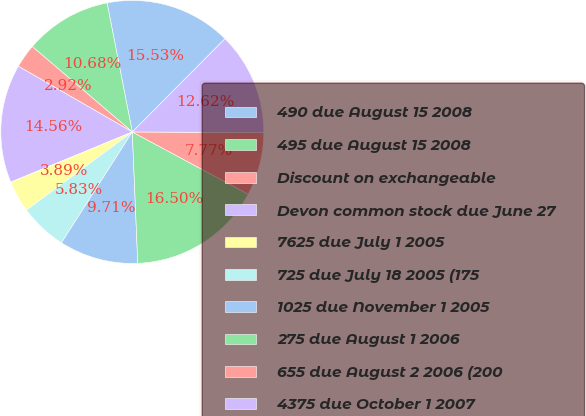Convert chart to OTSL. <chart><loc_0><loc_0><loc_500><loc_500><pie_chart><fcel>490 due August 15 2008<fcel>495 due August 15 2008<fcel>Discount on exchangeable<fcel>Devon common stock due June 27<fcel>7625 due July 1 2005<fcel>725 due July 18 2005 (175<fcel>1025 due November 1 2005<fcel>275 due August 1 2006<fcel>655 due August 2 2006 (200<fcel>4375 due October 1 2007<nl><fcel>15.53%<fcel>10.68%<fcel>2.92%<fcel>14.56%<fcel>3.89%<fcel>5.83%<fcel>9.71%<fcel>16.5%<fcel>7.77%<fcel>12.62%<nl></chart> 